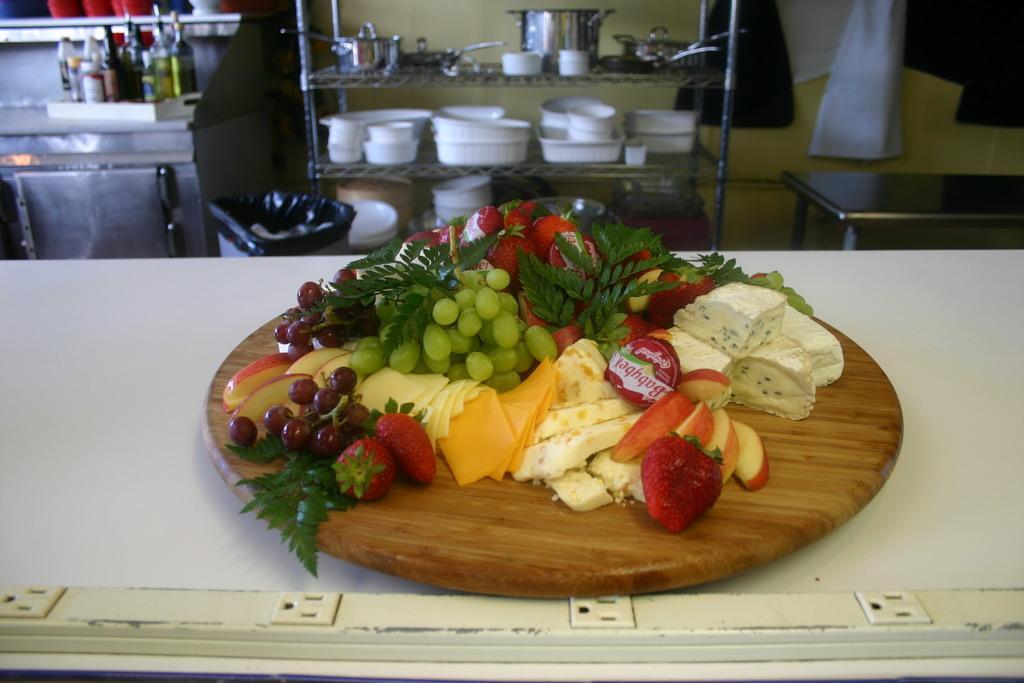Could you give a brief overview of what you see in this image? As we can see in the image there is a wall, table and rack. There are bowls, bottles and different types of fruits. 